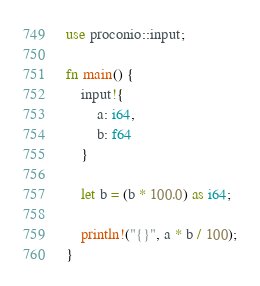Convert code to text. <code><loc_0><loc_0><loc_500><loc_500><_Rust_>use proconio::input;

fn main() {
    input!{
        a: i64,
        b: f64
    }

    let b = (b * 100.0) as i64;

    println!("{}", a * b / 100);
}
</code> 